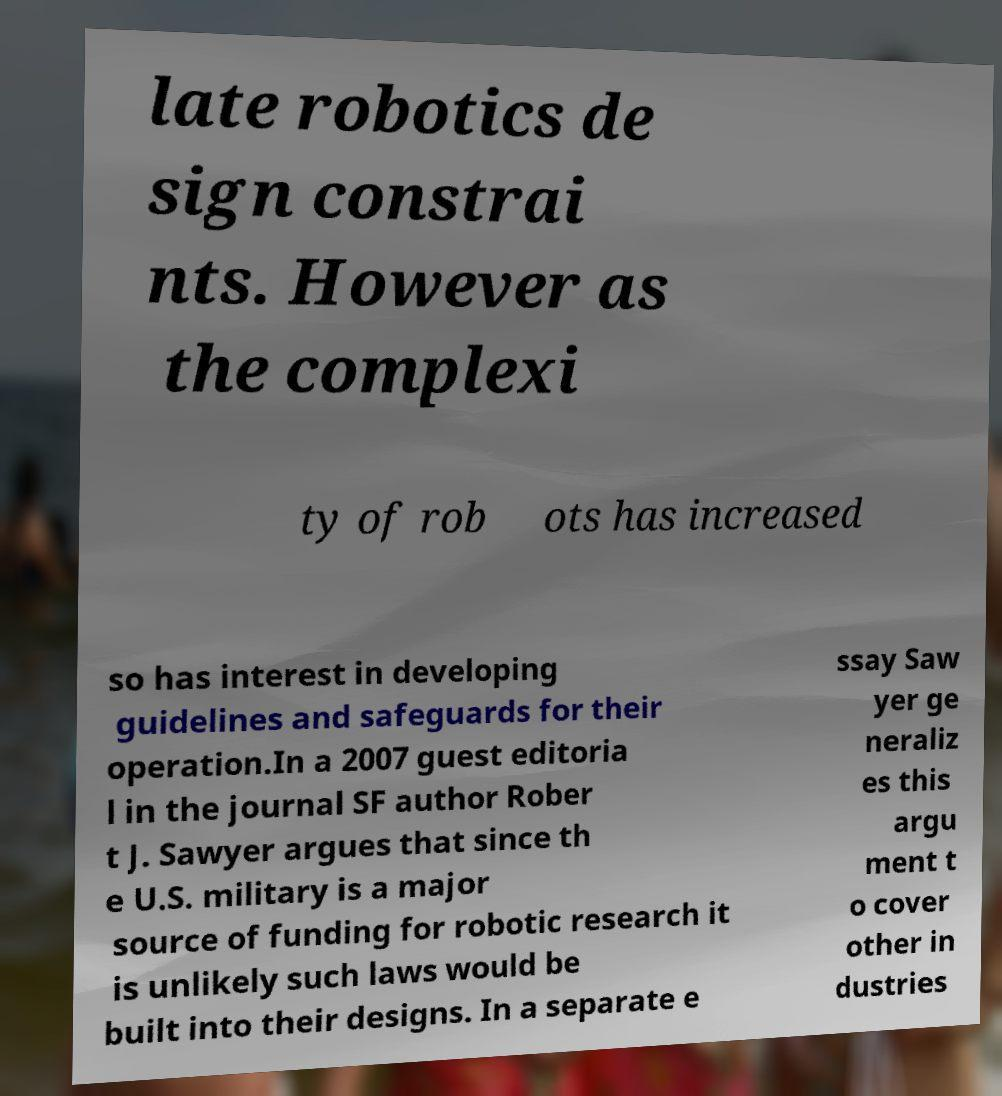There's text embedded in this image that I need extracted. Can you transcribe it verbatim? late robotics de sign constrai nts. However as the complexi ty of rob ots has increased so has interest in developing guidelines and safeguards for their operation.In a 2007 guest editoria l in the journal SF author Rober t J. Sawyer argues that since th e U.S. military is a major source of funding for robotic research it is unlikely such laws would be built into their designs. In a separate e ssay Saw yer ge neraliz es this argu ment t o cover other in dustries 